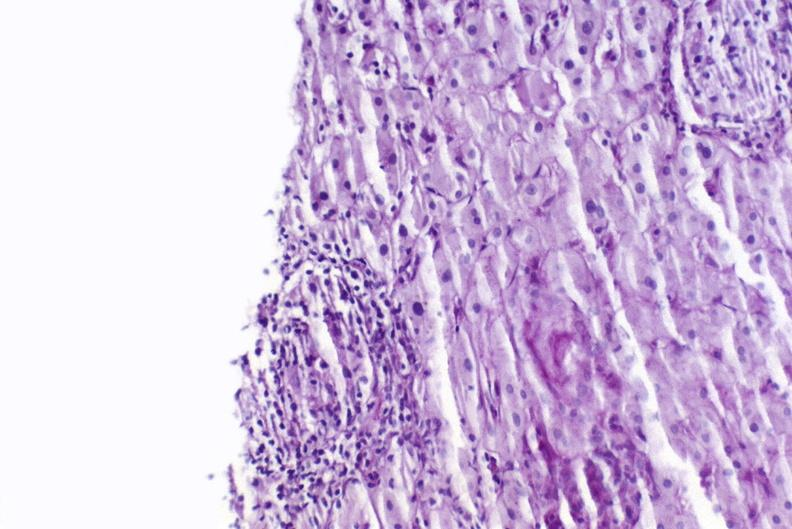what is present?
Answer the question using a single word or phrase. Liver 